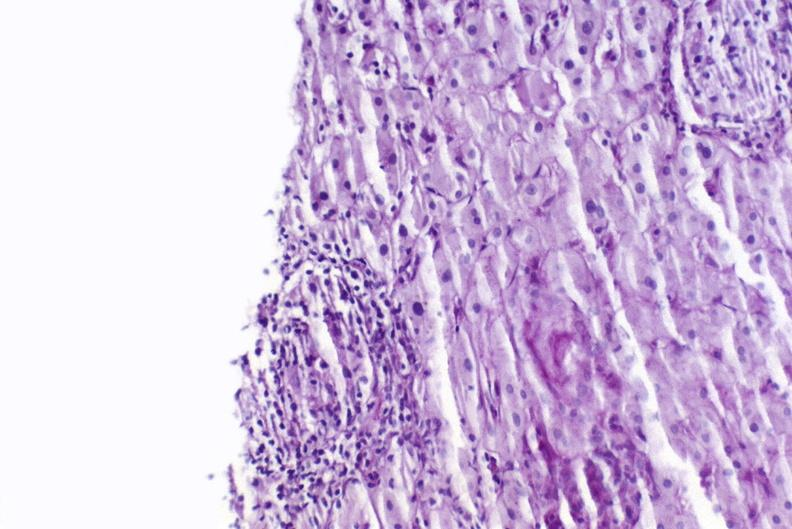what is present?
Answer the question using a single word or phrase. Liver 